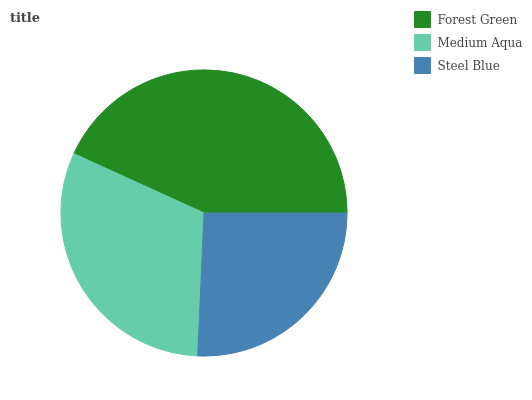Is Steel Blue the minimum?
Answer yes or no. Yes. Is Forest Green the maximum?
Answer yes or no. Yes. Is Medium Aqua the minimum?
Answer yes or no. No. Is Medium Aqua the maximum?
Answer yes or no. No. Is Forest Green greater than Medium Aqua?
Answer yes or no. Yes. Is Medium Aqua less than Forest Green?
Answer yes or no. Yes. Is Medium Aqua greater than Forest Green?
Answer yes or no. No. Is Forest Green less than Medium Aqua?
Answer yes or no. No. Is Medium Aqua the high median?
Answer yes or no. Yes. Is Medium Aqua the low median?
Answer yes or no. Yes. Is Forest Green the high median?
Answer yes or no. No. Is Forest Green the low median?
Answer yes or no. No. 